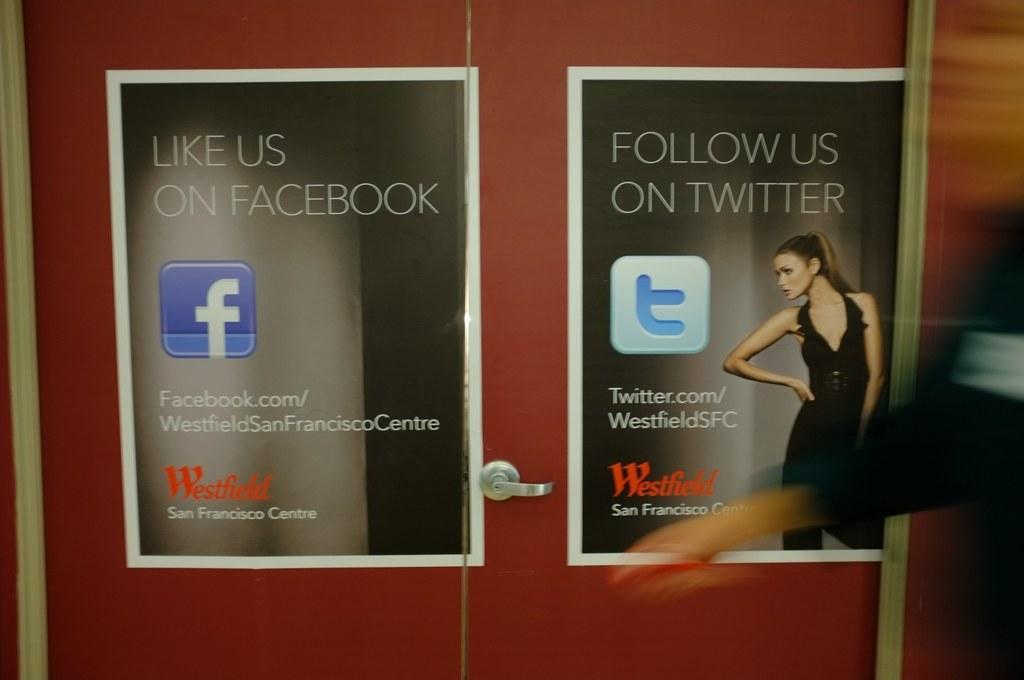How would you summarize this image in a sentence or two? In this picture there is a cupboard in the center of the image, on which there are posters. 